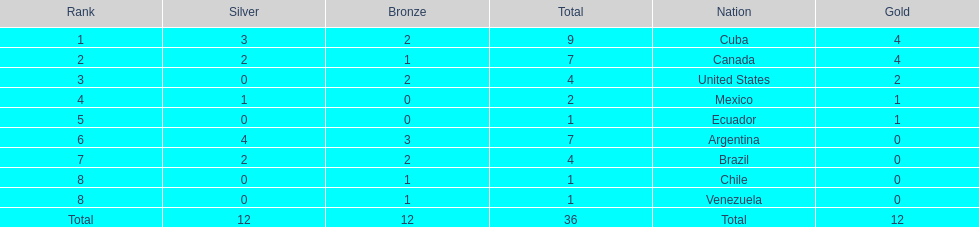Who had more silver medals, cuba or brazil? Cuba. 